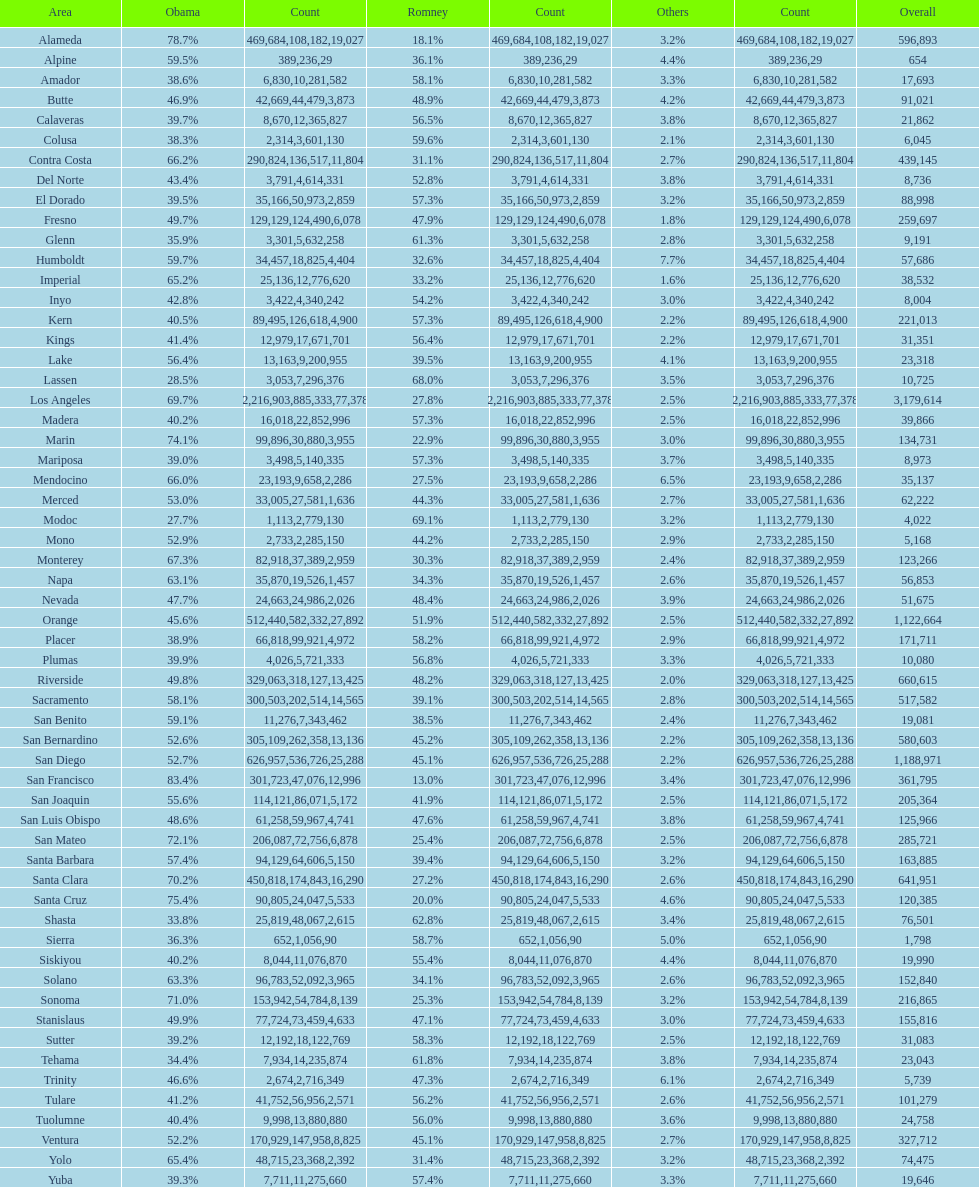What is the number of votes for obama for del norte and el dorado counties? 38957. Would you be able to parse every entry in this table? {'header': ['Area', 'Obama', 'Count', 'Romney', 'Count', 'Others', 'Count', 'Overall'], 'rows': [['Alameda', '78.7%', '469,684', '18.1%', '108,182', '3.2%', '19,027', '596,893'], ['Alpine', '59.5%', '389', '36.1%', '236', '4.4%', '29', '654'], ['Amador', '38.6%', '6,830', '58.1%', '10,281', '3.3%', '582', '17,693'], ['Butte', '46.9%', '42,669', '48.9%', '44,479', '4.2%', '3,873', '91,021'], ['Calaveras', '39.7%', '8,670', '56.5%', '12,365', '3.8%', '827', '21,862'], ['Colusa', '38.3%', '2,314', '59.6%', '3,601', '2.1%', '130', '6,045'], ['Contra Costa', '66.2%', '290,824', '31.1%', '136,517', '2.7%', '11,804', '439,145'], ['Del Norte', '43.4%', '3,791', '52.8%', '4,614', '3.8%', '331', '8,736'], ['El Dorado', '39.5%', '35,166', '57.3%', '50,973', '3.2%', '2,859', '88,998'], ['Fresno', '49.7%', '129,129', '47.9%', '124,490', '1.8%', '6,078', '259,697'], ['Glenn', '35.9%', '3,301', '61.3%', '5,632', '2.8%', '258', '9,191'], ['Humboldt', '59.7%', '34,457', '32.6%', '18,825', '7.7%', '4,404', '57,686'], ['Imperial', '65.2%', '25,136', '33.2%', '12,776', '1.6%', '620', '38,532'], ['Inyo', '42.8%', '3,422', '54.2%', '4,340', '3.0%', '242', '8,004'], ['Kern', '40.5%', '89,495', '57.3%', '126,618', '2.2%', '4,900', '221,013'], ['Kings', '41.4%', '12,979', '56.4%', '17,671', '2.2%', '701', '31,351'], ['Lake', '56.4%', '13,163', '39.5%', '9,200', '4.1%', '955', '23,318'], ['Lassen', '28.5%', '3,053', '68.0%', '7,296', '3.5%', '376', '10,725'], ['Los Angeles', '69.7%', '2,216,903', '27.8%', '885,333', '2.5%', '77,378', '3,179,614'], ['Madera', '40.2%', '16,018', '57.3%', '22,852', '2.5%', '996', '39,866'], ['Marin', '74.1%', '99,896', '22.9%', '30,880', '3.0%', '3,955', '134,731'], ['Mariposa', '39.0%', '3,498', '57.3%', '5,140', '3.7%', '335', '8,973'], ['Mendocino', '66.0%', '23,193', '27.5%', '9,658', '6.5%', '2,286', '35,137'], ['Merced', '53.0%', '33,005', '44.3%', '27,581', '2.7%', '1,636', '62,222'], ['Modoc', '27.7%', '1,113', '69.1%', '2,779', '3.2%', '130', '4,022'], ['Mono', '52.9%', '2,733', '44.2%', '2,285', '2.9%', '150', '5,168'], ['Monterey', '67.3%', '82,918', '30.3%', '37,389', '2.4%', '2,959', '123,266'], ['Napa', '63.1%', '35,870', '34.3%', '19,526', '2.6%', '1,457', '56,853'], ['Nevada', '47.7%', '24,663', '48.4%', '24,986', '3.9%', '2,026', '51,675'], ['Orange', '45.6%', '512,440', '51.9%', '582,332', '2.5%', '27,892', '1,122,664'], ['Placer', '38.9%', '66,818', '58.2%', '99,921', '2.9%', '4,972', '171,711'], ['Plumas', '39.9%', '4,026', '56.8%', '5,721', '3.3%', '333', '10,080'], ['Riverside', '49.8%', '329,063', '48.2%', '318,127', '2.0%', '13,425', '660,615'], ['Sacramento', '58.1%', '300,503', '39.1%', '202,514', '2.8%', '14,565', '517,582'], ['San Benito', '59.1%', '11,276', '38.5%', '7,343', '2.4%', '462', '19,081'], ['San Bernardino', '52.6%', '305,109', '45.2%', '262,358', '2.2%', '13,136', '580,603'], ['San Diego', '52.7%', '626,957', '45.1%', '536,726', '2.2%', '25,288', '1,188,971'], ['San Francisco', '83.4%', '301,723', '13.0%', '47,076', '3.4%', '12,996', '361,795'], ['San Joaquin', '55.6%', '114,121', '41.9%', '86,071', '2.5%', '5,172', '205,364'], ['San Luis Obispo', '48.6%', '61,258', '47.6%', '59,967', '3.8%', '4,741', '125,966'], ['San Mateo', '72.1%', '206,087', '25.4%', '72,756', '2.5%', '6,878', '285,721'], ['Santa Barbara', '57.4%', '94,129', '39.4%', '64,606', '3.2%', '5,150', '163,885'], ['Santa Clara', '70.2%', '450,818', '27.2%', '174,843', '2.6%', '16,290', '641,951'], ['Santa Cruz', '75.4%', '90,805', '20.0%', '24,047', '4.6%', '5,533', '120,385'], ['Shasta', '33.8%', '25,819', '62.8%', '48,067', '3.4%', '2,615', '76,501'], ['Sierra', '36.3%', '652', '58.7%', '1,056', '5.0%', '90', '1,798'], ['Siskiyou', '40.2%', '8,044', '55.4%', '11,076', '4.4%', '870', '19,990'], ['Solano', '63.3%', '96,783', '34.1%', '52,092', '2.6%', '3,965', '152,840'], ['Sonoma', '71.0%', '153,942', '25.3%', '54,784', '3.2%', '8,139', '216,865'], ['Stanislaus', '49.9%', '77,724', '47.1%', '73,459', '3.0%', '4,633', '155,816'], ['Sutter', '39.2%', '12,192', '58.3%', '18,122', '2.5%', '769', '31,083'], ['Tehama', '34.4%', '7,934', '61.8%', '14,235', '3.8%', '874', '23,043'], ['Trinity', '46.6%', '2,674', '47.3%', '2,716', '6.1%', '349', '5,739'], ['Tulare', '41.2%', '41,752', '56.2%', '56,956', '2.6%', '2,571', '101,279'], ['Tuolumne', '40.4%', '9,998', '56.0%', '13,880', '3.6%', '880', '24,758'], ['Ventura', '52.2%', '170,929', '45.1%', '147,958', '2.7%', '8,825', '327,712'], ['Yolo', '65.4%', '48,715', '31.4%', '23,368', '3.2%', '2,392', '74,475'], ['Yuba', '39.3%', '7,711', '57.4%', '11,275', '3.3%', '660', '19,646']]} 